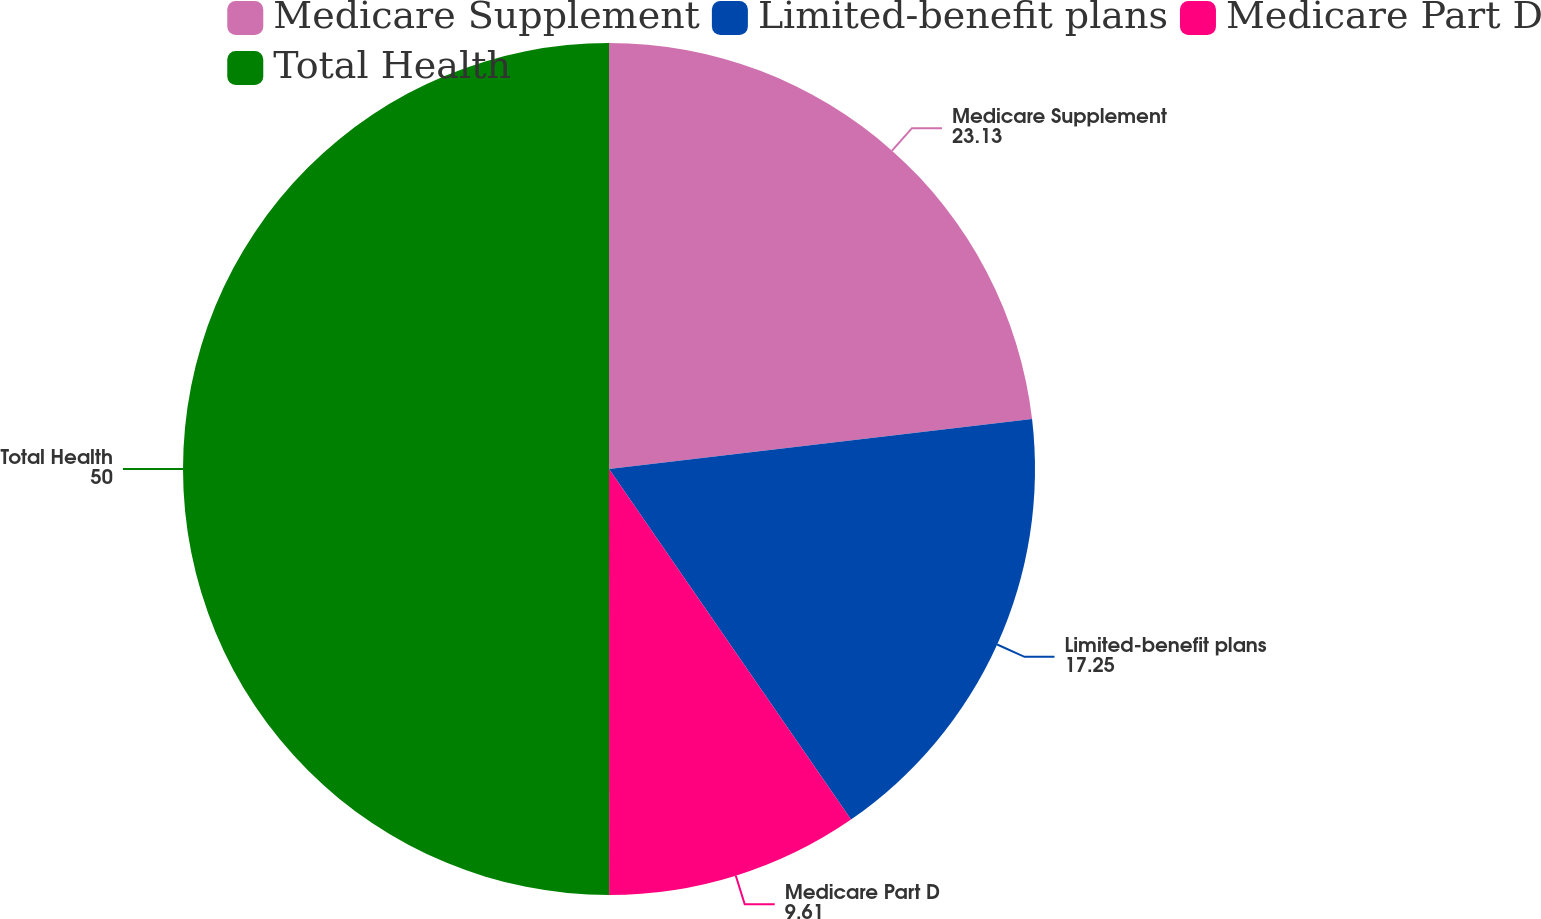<chart> <loc_0><loc_0><loc_500><loc_500><pie_chart><fcel>Medicare Supplement<fcel>Limited-benefit plans<fcel>Medicare Part D<fcel>Total Health<nl><fcel>23.13%<fcel>17.25%<fcel>9.61%<fcel>50.0%<nl></chart> 